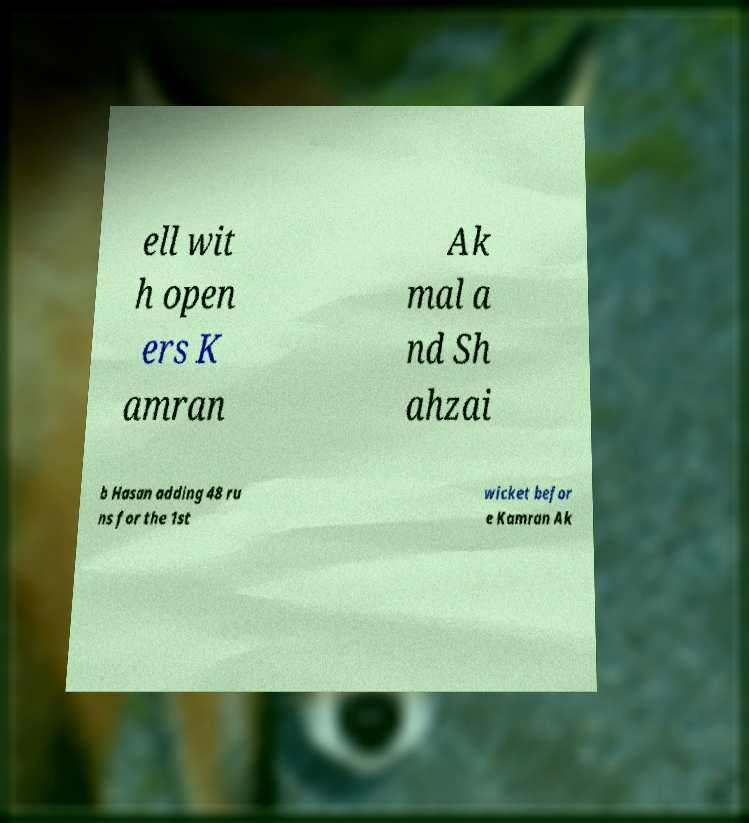Please identify and transcribe the text found in this image. ell wit h open ers K amran Ak mal a nd Sh ahzai b Hasan adding 48 ru ns for the 1st wicket befor e Kamran Ak 